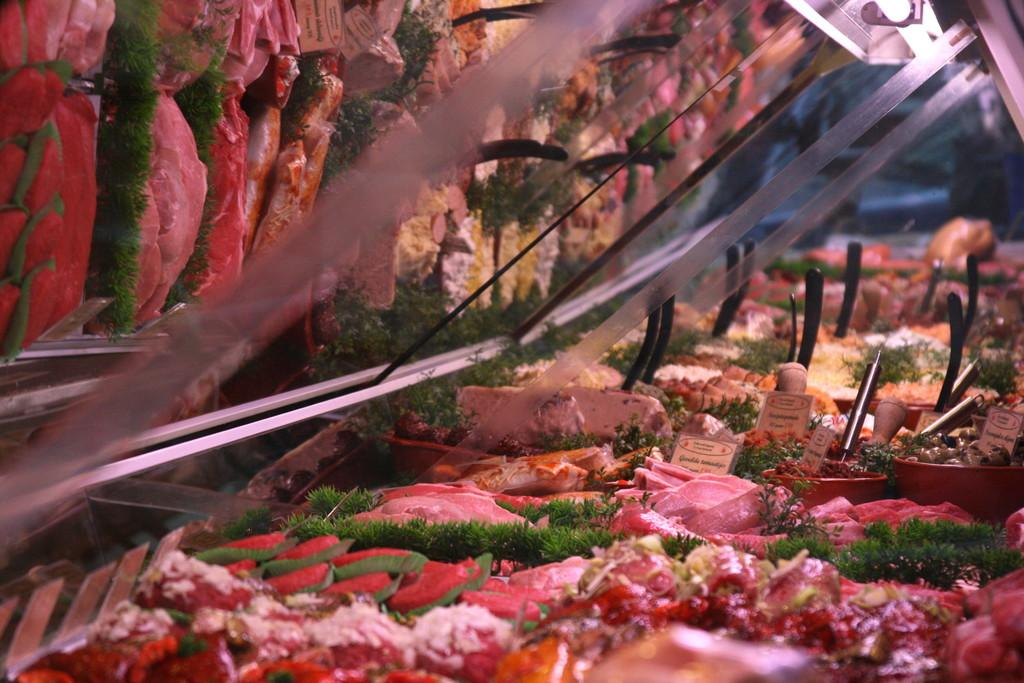What types of food items can be seen in the image? There are different food items in the image. What are the food items contained in? There are bowls in the image. What other objects can be seen in the image besides food items and bowls? There are boards in the image. Where is the glass located in the image? The glass is at the top of the image. What type of rod is being used by the secretary in the image? There is no secretary or rod present in the image. How many nails can be seen in the image? There are no nails visible in the image. 